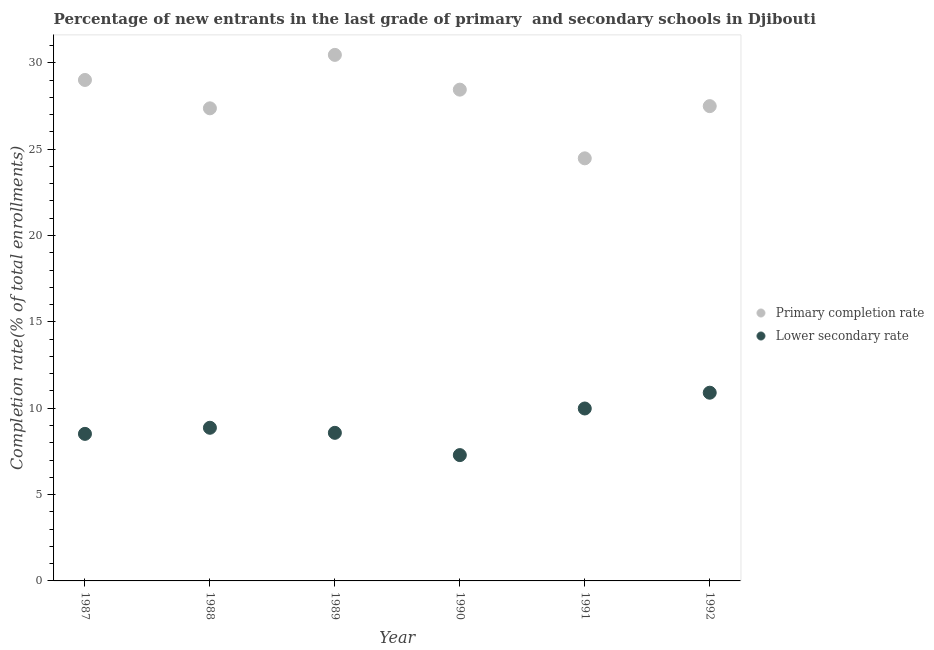What is the completion rate in primary schools in 1989?
Offer a terse response. 30.46. Across all years, what is the maximum completion rate in secondary schools?
Your response must be concise. 10.9. Across all years, what is the minimum completion rate in secondary schools?
Provide a short and direct response. 7.29. In which year was the completion rate in primary schools maximum?
Offer a terse response. 1989. In which year was the completion rate in secondary schools minimum?
Your answer should be very brief. 1990. What is the total completion rate in primary schools in the graph?
Provide a short and direct response. 167.23. What is the difference between the completion rate in secondary schools in 1987 and that in 1989?
Make the answer very short. -0.06. What is the difference between the completion rate in secondary schools in 1990 and the completion rate in primary schools in 1991?
Give a very brief answer. -17.18. What is the average completion rate in primary schools per year?
Provide a short and direct response. 27.87. In the year 1988, what is the difference between the completion rate in primary schools and completion rate in secondary schools?
Offer a very short reply. 18.5. In how many years, is the completion rate in secondary schools greater than 26 %?
Your answer should be compact. 0. What is the ratio of the completion rate in primary schools in 1987 to that in 1990?
Your answer should be compact. 1.02. What is the difference between the highest and the second highest completion rate in secondary schools?
Your answer should be very brief. 0.91. What is the difference between the highest and the lowest completion rate in primary schools?
Give a very brief answer. 5.99. In how many years, is the completion rate in primary schools greater than the average completion rate in primary schools taken over all years?
Make the answer very short. 3. Is the completion rate in secondary schools strictly greater than the completion rate in primary schools over the years?
Your response must be concise. No. Is the completion rate in secondary schools strictly less than the completion rate in primary schools over the years?
Provide a short and direct response. Yes. How many years are there in the graph?
Make the answer very short. 6. Does the graph contain any zero values?
Your answer should be compact. No. Does the graph contain grids?
Provide a short and direct response. No. How many legend labels are there?
Ensure brevity in your answer.  2. What is the title of the graph?
Provide a succinct answer. Percentage of new entrants in the last grade of primary  and secondary schools in Djibouti. Does "Methane emissions" appear as one of the legend labels in the graph?
Give a very brief answer. No. What is the label or title of the X-axis?
Your response must be concise. Year. What is the label or title of the Y-axis?
Make the answer very short. Completion rate(% of total enrollments). What is the Completion rate(% of total enrollments) of Primary completion rate in 1987?
Offer a very short reply. 29. What is the Completion rate(% of total enrollments) of Lower secondary rate in 1987?
Offer a very short reply. 8.51. What is the Completion rate(% of total enrollments) of Primary completion rate in 1988?
Give a very brief answer. 27.36. What is the Completion rate(% of total enrollments) in Lower secondary rate in 1988?
Provide a succinct answer. 8.87. What is the Completion rate(% of total enrollments) of Primary completion rate in 1989?
Your answer should be very brief. 30.46. What is the Completion rate(% of total enrollments) of Lower secondary rate in 1989?
Your response must be concise. 8.57. What is the Completion rate(% of total enrollments) in Primary completion rate in 1990?
Provide a short and direct response. 28.44. What is the Completion rate(% of total enrollments) of Lower secondary rate in 1990?
Your answer should be very brief. 7.29. What is the Completion rate(% of total enrollments) of Primary completion rate in 1991?
Keep it short and to the point. 24.47. What is the Completion rate(% of total enrollments) in Lower secondary rate in 1991?
Keep it short and to the point. 9.98. What is the Completion rate(% of total enrollments) in Primary completion rate in 1992?
Your response must be concise. 27.49. What is the Completion rate(% of total enrollments) in Lower secondary rate in 1992?
Keep it short and to the point. 10.9. Across all years, what is the maximum Completion rate(% of total enrollments) in Primary completion rate?
Your answer should be very brief. 30.46. Across all years, what is the maximum Completion rate(% of total enrollments) of Lower secondary rate?
Offer a very short reply. 10.9. Across all years, what is the minimum Completion rate(% of total enrollments) in Primary completion rate?
Provide a short and direct response. 24.47. Across all years, what is the minimum Completion rate(% of total enrollments) of Lower secondary rate?
Your answer should be compact. 7.29. What is the total Completion rate(% of total enrollments) of Primary completion rate in the graph?
Offer a very short reply. 167.23. What is the total Completion rate(% of total enrollments) of Lower secondary rate in the graph?
Your answer should be compact. 54.12. What is the difference between the Completion rate(% of total enrollments) in Primary completion rate in 1987 and that in 1988?
Provide a short and direct response. 1.64. What is the difference between the Completion rate(% of total enrollments) in Lower secondary rate in 1987 and that in 1988?
Give a very brief answer. -0.35. What is the difference between the Completion rate(% of total enrollments) of Primary completion rate in 1987 and that in 1989?
Your response must be concise. -1.45. What is the difference between the Completion rate(% of total enrollments) in Lower secondary rate in 1987 and that in 1989?
Give a very brief answer. -0.06. What is the difference between the Completion rate(% of total enrollments) of Primary completion rate in 1987 and that in 1990?
Give a very brief answer. 0.56. What is the difference between the Completion rate(% of total enrollments) in Lower secondary rate in 1987 and that in 1990?
Provide a succinct answer. 1.23. What is the difference between the Completion rate(% of total enrollments) in Primary completion rate in 1987 and that in 1991?
Your response must be concise. 4.54. What is the difference between the Completion rate(% of total enrollments) in Lower secondary rate in 1987 and that in 1991?
Ensure brevity in your answer.  -1.47. What is the difference between the Completion rate(% of total enrollments) in Primary completion rate in 1987 and that in 1992?
Offer a terse response. 1.51. What is the difference between the Completion rate(% of total enrollments) of Lower secondary rate in 1987 and that in 1992?
Make the answer very short. -2.38. What is the difference between the Completion rate(% of total enrollments) of Primary completion rate in 1988 and that in 1989?
Offer a terse response. -3.09. What is the difference between the Completion rate(% of total enrollments) of Lower secondary rate in 1988 and that in 1989?
Ensure brevity in your answer.  0.29. What is the difference between the Completion rate(% of total enrollments) in Primary completion rate in 1988 and that in 1990?
Provide a succinct answer. -1.08. What is the difference between the Completion rate(% of total enrollments) in Lower secondary rate in 1988 and that in 1990?
Make the answer very short. 1.58. What is the difference between the Completion rate(% of total enrollments) in Primary completion rate in 1988 and that in 1991?
Make the answer very short. 2.9. What is the difference between the Completion rate(% of total enrollments) of Lower secondary rate in 1988 and that in 1991?
Your answer should be compact. -1.12. What is the difference between the Completion rate(% of total enrollments) of Primary completion rate in 1988 and that in 1992?
Ensure brevity in your answer.  -0.13. What is the difference between the Completion rate(% of total enrollments) in Lower secondary rate in 1988 and that in 1992?
Offer a very short reply. -2.03. What is the difference between the Completion rate(% of total enrollments) in Primary completion rate in 1989 and that in 1990?
Your answer should be compact. 2.01. What is the difference between the Completion rate(% of total enrollments) in Lower secondary rate in 1989 and that in 1990?
Your response must be concise. 1.29. What is the difference between the Completion rate(% of total enrollments) of Primary completion rate in 1989 and that in 1991?
Make the answer very short. 5.99. What is the difference between the Completion rate(% of total enrollments) in Lower secondary rate in 1989 and that in 1991?
Make the answer very short. -1.41. What is the difference between the Completion rate(% of total enrollments) in Primary completion rate in 1989 and that in 1992?
Keep it short and to the point. 2.97. What is the difference between the Completion rate(% of total enrollments) of Lower secondary rate in 1989 and that in 1992?
Keep it short and to the point. -2.32. What is the difference between the Completion rate(% of total enrollments) in Primary completion rate in 1990 and that in 1991?
Offer a very short reply. 3.98. What is the difference between the Completion rate(% of total enrollments) of Lower secondary rate in 1990 and that in 1991?
Your answer should be very brief. -2.7. What is the difference between the Completion rate(% of total enrollments) in Primary completion rate in 1990 and that in 1992?
Your answer should be very brief. 0.95. What is the difference between the Completion rate(% of total enrollments) in Lower secondary rate in 1990 and that in 1992?
Your answer should be compact. -3.61. What is the difference between the Completion rate(% of total enrollments) of Primary completion rate in 1991 and that in 1992?
Offer a very short reply. -3.02. What is the difference between the Completion rate(% of total enrollments) in Lower secondary rate in 1991 and that in 1992?
Keep it short and to the point. -0.91. What is the difference between the Completion rate(% of total enrollments) in Primary completion rate in 1987 and the Completion rate(% of total enrollments) in Lower secondary rate in 1988?
Your response must be concise. 20.14. What is the difference between the Completion rate(% of total enrollments) in Primary completion rate in 1987 and the Completion rate(% of total enrollments) in Lower secondary rate in 1989?
Offer a very short reply. 20.43. What is the difference between the Completion rate(% of total enrollments) of Primary completion rate in 1987 and the Completion rate(% of total enrollments) of Lower secondary rate in 1990?
Your answer should be very brief. 21.72. What is the difference between the Completion rate(% of total enrollments) in Primary completion rate in 1987 and the Completion rate(% of total enrollments) in Lower secondary rate in 1991?
Your response must be concise. 19.02. What is the difference between the Completion rate(% of total enrollments) of Primary completion rate in 1987 and the Completion rate(% of total enrollments) of Lower secondary rate in 1992?
Your answer should be compact. 18.11. What is the difference between the Completion rate(% of total enrollments) of Primary completion rate in 1988 and the Completion rate(% of total enrollments) of Lower secondary rate in 1989?
Keep it short and to the point. 18.79. What is the difference between the Completion rate(% of total enrollments) of Primary completion rate in 1988 and the Completion rate(% of total enrollments) of Lower secondary rate in 1990?
Your answer should be very brief. 20.08. What is the difference between the Completion rate(% of total enrollments) of Primary completion rate in 1988 and the Completion rate(% of total enrollments) of Lower secondary rate in 1991?
Your answer should be very brief. 17.38. What is the difference between the Completion rate(% of total enrollments) in Primary completion rate in 1988 and the Completion rate(% of total enrollments) in Lower secondary rate in 1992?
Ensure brevity in your answer.  16.47. What is the difference between the Completion rate(% of total enrollments) in Primary completion rate in 1989 and the Completion rate(% of total enrollments) in Lower secondary rate in 1990?
Your answer should be very brief. 23.17. What is the difference between the Completion rate(% of total enrollments) in Primary completion rate in 1989 and the Completion rate(% of total enrollments) in Lower secondary rate in 1991?
Make the answer very short. 20.47. What is the difference between the Completion rate(% of total enrollments) of Primary completion rate in 1989 and the Completion rate(% of total enrollments) of Lower secondary rate in 1992?
Ensure brevity in your answer.  19.56. What is the difference between the Completion rate(% of total enrollments) of Primary completion rate in 1990 and the Completion rate(% of total enrollments) of Lower secondary rate in 1991?
Keep it short and to the point. 18.46. What is the difference between the Completion rate(% of total enrollments) in Primary completion rate in 1990 and the Completion rate(% of total enrollments) in Lower secondary rate in 1992?
Offer a terse response. 17.55. What is the difference between the Completion rate(% of total enrollments) in Primary completion rate in 1991 and the Completion rate(% of total enrollments) in Lower secondary rate in 1992?
Offer a terse response. 13.57. What is the average Completion rate(% of total enrollments) of Primary completion rate per year?
Your answer should be very brief. 27.87. What is the average Completion rate(% of total enrollments) of Lower secondary rate per year?
Ensure brevity in your answer.  9.02. In the year 1987, what is the difference between the Completion rate(% of total enrollments) in Primary completion rate and Completion rate(% of total enrollments) in Lower secondary rate?
Ensure brevity in your answer.  20.49. In the year 1988, what is the difference between the Completion rate(% of total enrollments) of Primary completion rate and Completion rate(% of total enrollments) of Lower secondary rate?
Ensure brevity in your answer.  18.5. In the year 1989, what is the difference between the Completion rate(% of total enrollments) of Primary completion rate and Completion rate(% of total enrollments) of Lower secondary rate?
Make the answer very short. 21.88. In the year 1990, what is the difference between the Completion rate(% of total enrollments) in Primary completion rate and Completion rate(% of total enrollments) in Lower secondary rate?
Your answer should be very brief. 21.16. In the year 1991, what is the difference between the Completion rate(% of total enrollments) of Primary completion rate and Completion rate(% of total enrollments) of Lower secondary rate?
Give a very brief answer. 14.48. In the year 1992, what is the difference between the Completion rate(% of total enrollments) of Primary completion rate and Completion rate(% of total enrollments) of Lower secondary rate?
Make the answer very short. 16.59. What is the ratio of the Completion rate(% of total enrollments) of Primary completion rate in 1987 to that in 1988?
Keep it short and to the point. 1.06. What is the ratio of the Completion rate(% of total enrollments) in Lower secondary rate in 1987 to that in 1988?
Provide a short and direct response. 0.96. What is the ratio of the Completion rate(% of total enrollments) in Primary completion rate in 1987 to that in 1989?
Give a very brief answer. 0.95. What is the ratio of the Completion rate(% of total enrollments) of Primary completion rate in 1987 to that in 1990?
Provide a short and direct response. 1.02. What is the ratio of the Completion rate(% of total enrollments) in Lower secondary rate in 1987 to that in 1990?
Your answer should be compact. 1.17. What is the ratio of the Completion rate(% of total enrollments) of Primary completion rate in 1987 to that in 1991?
Your response must be concise. 1.19. What is the ratio of the Completion rate(% of total enrollments) in Lower secondary rate in 1987 to that in 1991?
Your answer should be compact. 0.85. What is the ratio of the Completion rate(% of total enrollments) of Primary completion rate in 1987 to that in 1992?
Ensure brevity in your answer.  1.06. What is the ratio of the Completion rate(% of total enrollments) of Lower secondary rate in 1987 to that in 1992?
Make the answer very short. 0.78. What is the ratio of the Completion rate(% of total enrollments) in Primary completion rate in 1988 to that in 1989?
Give a very brief answer. 0.9. What is the ratio of the Completion rate(% of total enrollments) in Lower secondary rate in 1988 to that in 1989?
Your response must be concise. 1.03. What is the ratio of the Completion rate(% of total enrollments) of Primary completion rate in 1988 to that in 1990?
Ensure brevity in your answer.  0.96. What is the ratio of the Completion rate(% of total enrollments) in Lower secondary rate in 1988 to that in 1990?
Make the answer very short. 1.22. What is the ratio of the Completion rate(% of total enrollments) of Primary completion rate in 1988 to that in 1991?
Your answer should be compact. 1.12. What is the ratio of the Completion rate(% of total enrollments) in Lower secondary rate in 1988 to that in 1991?
Provide a succinct answer. 0.89. What is the ratio of the Completion rate(% of total enrollments) of Lower secondary rate in 1988 to that in 1992?
Provide a succinct answer. 0.81. What is the ratio of the Completion rate(% of total enrollments) of Primary completion rate in 1989 to that in 1990?
Ensure brevity in your answer.  1.07. What is the ratio of the Completion rate(% of total enrollments) in Lower secondary rate in 1989 to that in 1990?
Offer a very short reply. 1.18. What is the ratio of the Completion rate(% of total enrollments) of Primary completion rate in 1989 to that in 1991?
Offer a terse response. 1.24. What is the ratio of the Completion rate(% of total enrollments) of Lower secondary rate in 1989 to that in 1991?
Your answer should be compact. 0.86. What is the ratio of the Completion rate(% of total enrollments) of Primary completion rate in 1989 to that in 1992?
Your answer should be very brief. 1.11. What is the ratio of the Completion rate(% of total enrollments) of Lower secondary rate in 1989 to that in 1992?
Offer a very short reply. 0.79. What is the ratio of the Completion rate(% of total enrollments) in Primary completion rate in 1990 to that in 1991?
Your response must be concise. 1.16. What is the ratio of the Completion rate(% of total enrollments) of Lower secondary rate in 1990 to that in 1991?
Offer a terse response. 0.73. What is the ratio of the Completion rate(% of total enrollments) in Primary completion rate in 1990 to that in 1992?
Make the answer very short. 1.03. What is the ratio of the Completion rate(% of total enrollments) in Lower secondary rate in 1990 to that in 1992?
Provide a succinct answer. 0.67. What is the ratio of the Completion rate(% of total enrollments) of Primary completion rate in 1991 to that in 1992?
Give a very brief answer. 0.89. What is the ratio of the Completion rate(% of total enrollments) of Lower secondary rate in 1991 to that in 1992?
Offer a terse response. 0.92. What is the difference between the highest and the second highest Completion rate(% of total enrollments) in Primary completion rate?
Provide a short and direct response. 1.45. What is the difference between the highest and the second highest Completion rate(% of total enrollments) of Lower secondary rate?
Offer a very short reply. 0.91. What is the difference between the highest and the lowest Completion rate(% of total enrollments) of Primary completion rate?
Your response must be concise. 5.99. What is the difference between the highest and the lowest Completion rate(% of total enrollments) in Lower secondary rate?
Your answer should be compact. 3.61. 